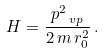Convert formula to latex. <formula><loc_0><loc_0><loc_500><loc_500>H = \frac { p _ { \ v p } ^ { 2 } } { 2 \, m \, r _ { 0 } ^ { 2 } } \, .</formula> 